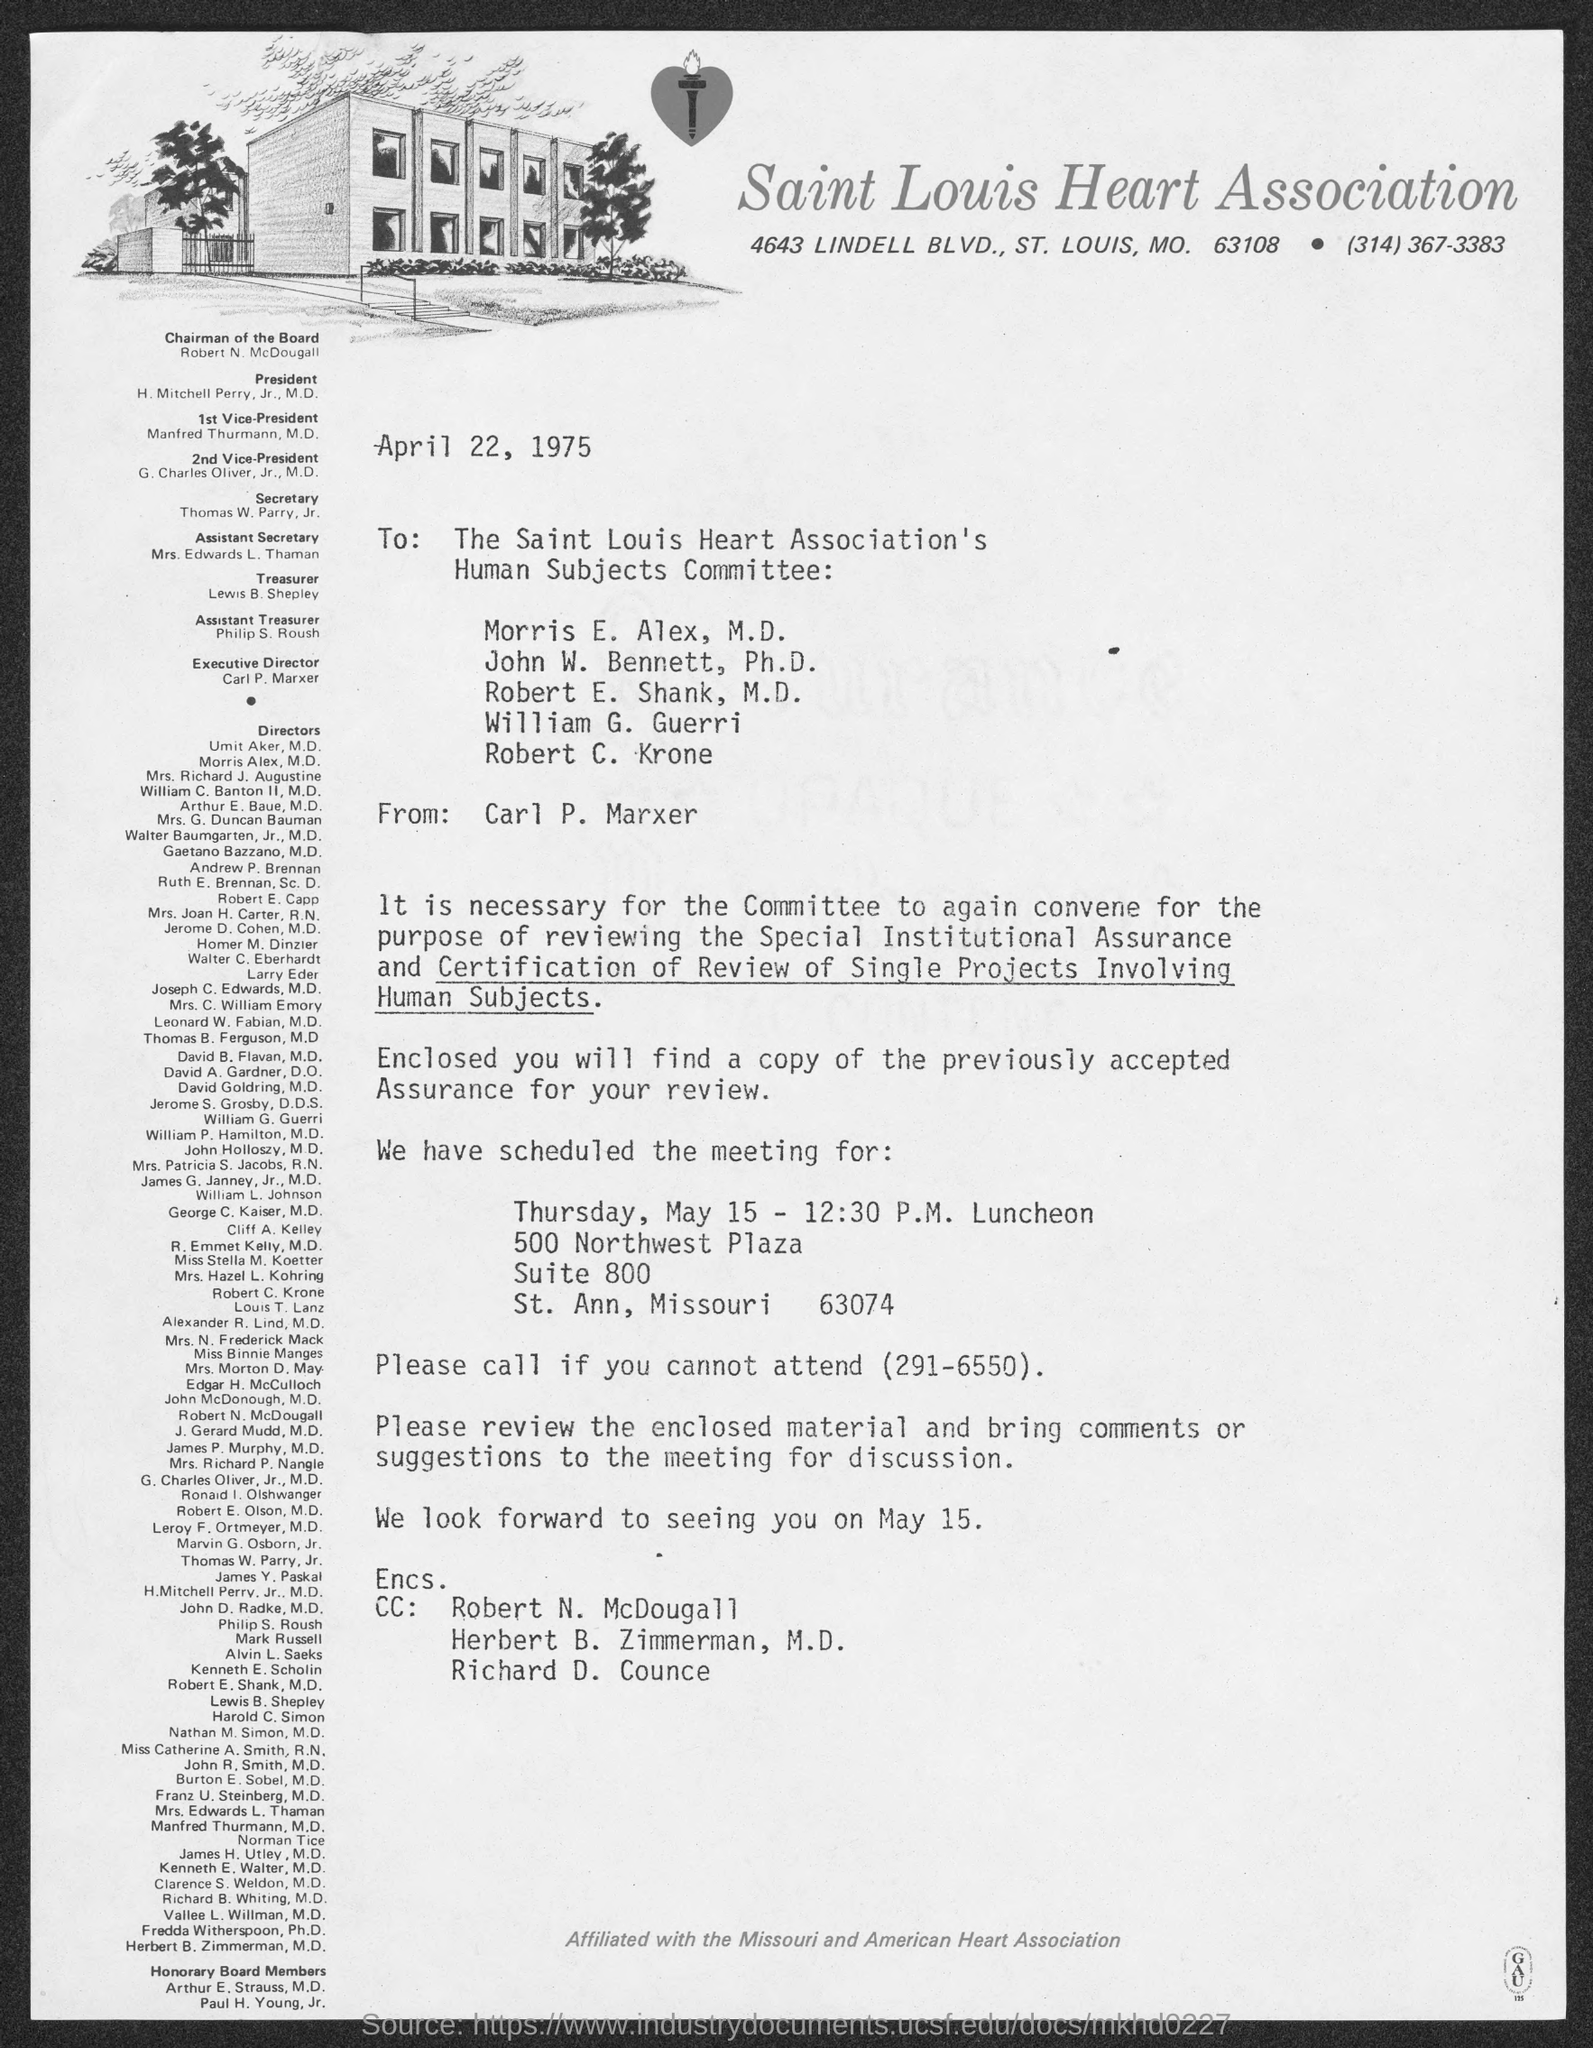What is the name of heart association ?
Your response must be concise. Saint Louis Heart Association. What is the street address of saint louis heart association ?
Provide a short and direct response. 4643 Lindell Blvd. When is the memorandum dated?
Give a very brief answer. April 22, 1975. Who is the chairman of the board ?
Give a very brief answer. Robert N. McDougall. Who is the president ?
Offer a terse response. H. Mitchell Perry, Jr., M.D. What is the position of mrs. edwards l. thaman ?
Provide a short and direct response. Assistant Secretary. What is the position of lewis b. shepley ?
Your response must be concise. Treasurer. 